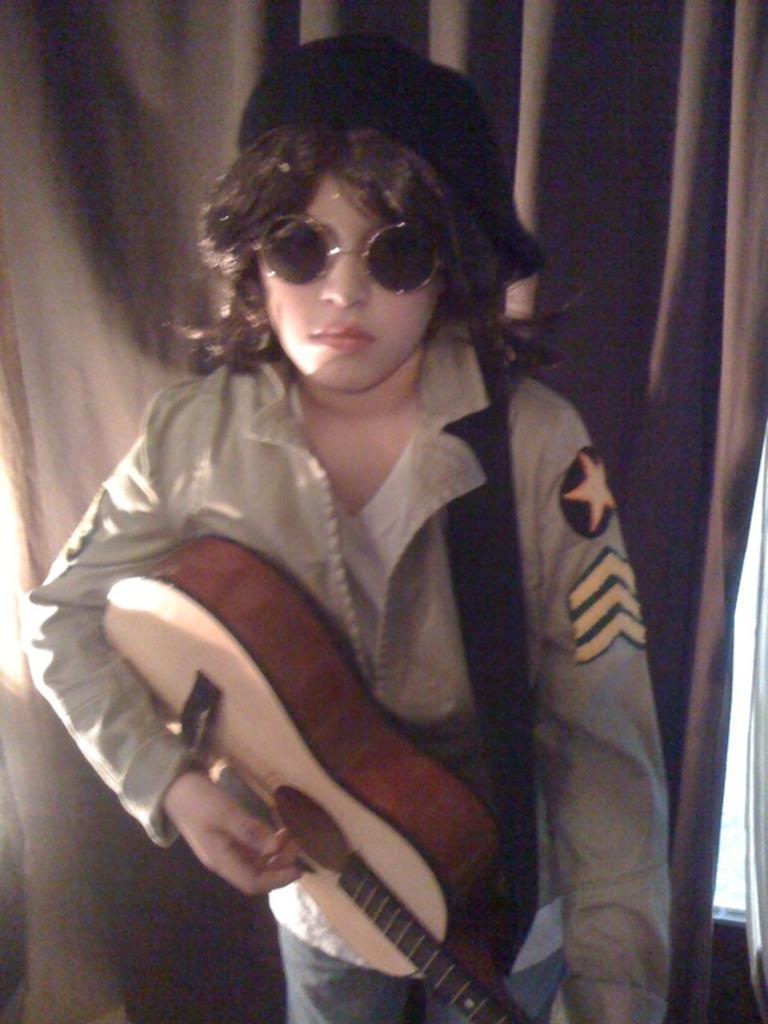Describe this image in one or two sentences. In this picture we can see a person standing and he is playing a guitar. 